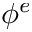<formula> <loc_0><loc_0><loc_500><loc_500>\phi ^ { e }</formula> 